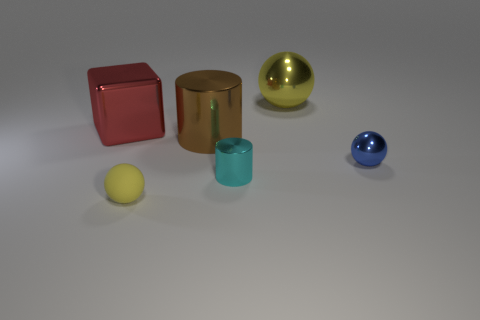Is the shape of the small object in front of the small cylinder the same as the yellow object that is behind the small yellow object?
Offer a terse response. Yes. What shape is the metal object that is left of the blue sphere and in front of the large brown object?
Ensure brevity in your answer.  Cylinder. Are there any metallic cylinders of the same size as the blue metal ball?
Your answer should be very brief. Yes. Does the tiny matte object have the same color as the metal ball behind the big red metallic object?
Keep it short and to the point. Yes. What is the large red object made of?
Your answer should be compact. Metal. There is a metallic ball that is in front of the shiny cube; what color is it?
Provide a short and direct response. Blue. How many spheres are the same color as the big block?
Ensure brevity in your answer.  0. What number of balls are right of the tiny yellow matte thing and in front of the metallic block?
Offer a very short reply. 1. The cyan object that is the same size as the yellow matte thing is what shape?
Keep it short and to the point. Cylinder. What is the size of the brown cylinder?
Make the answer very short. Large. 